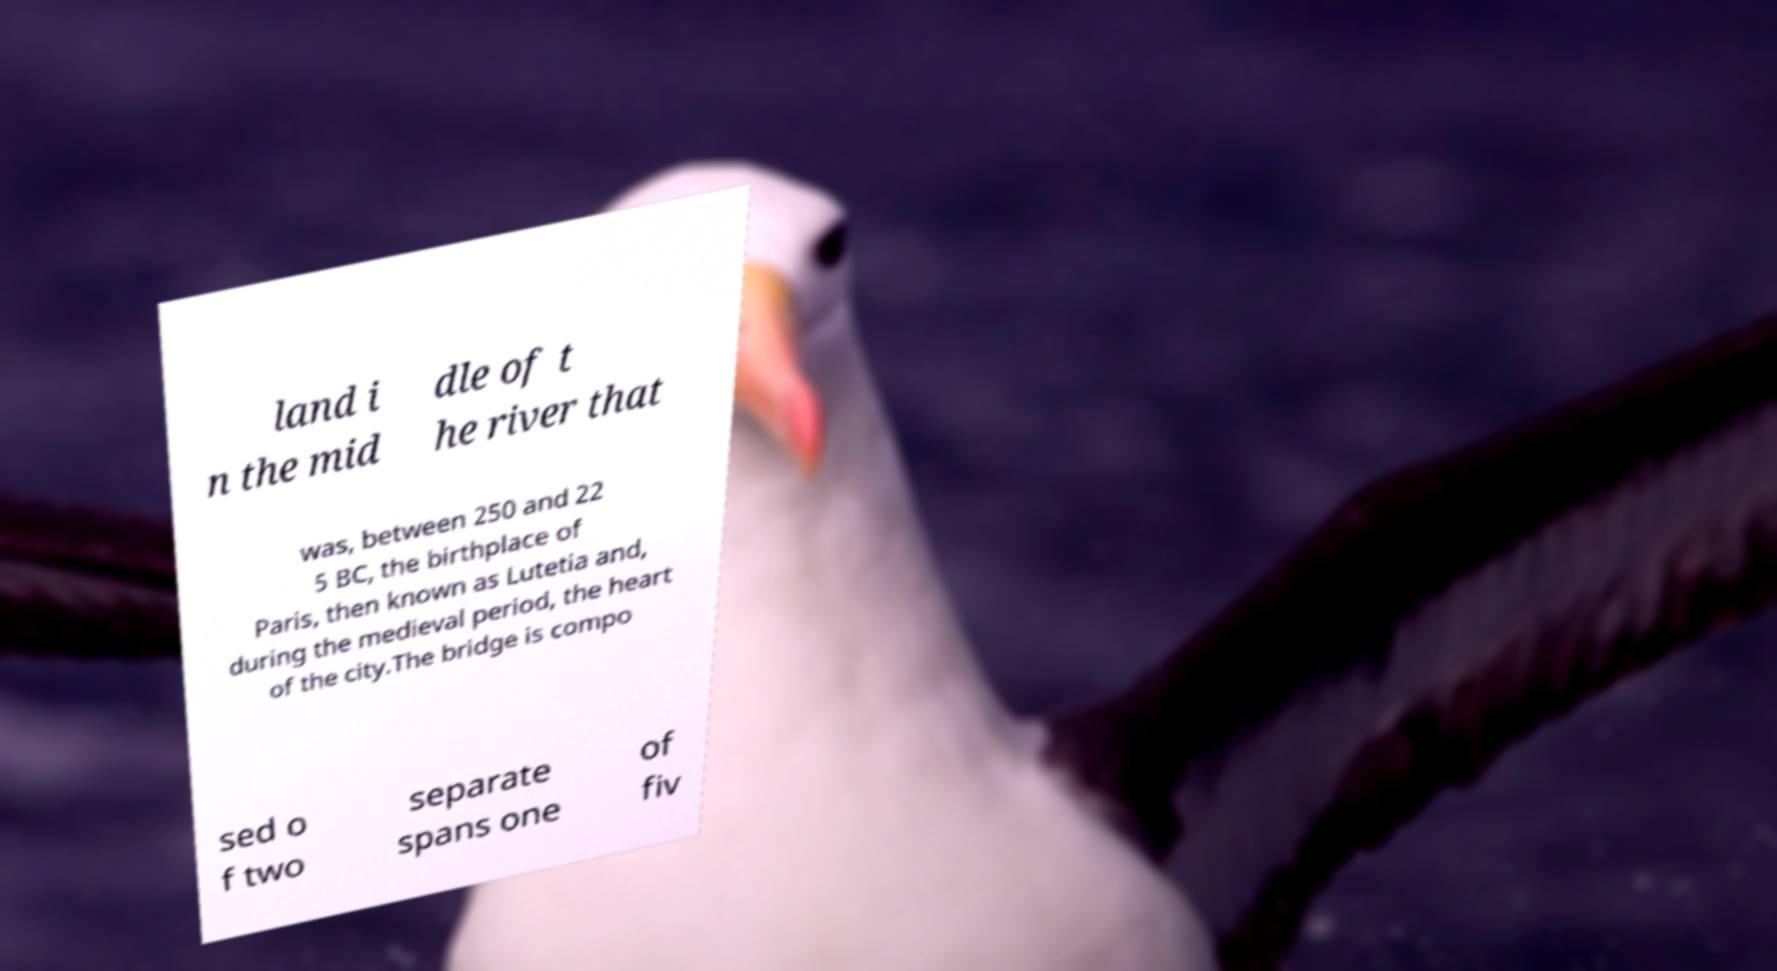For documentation purposes, I need the text within this image transcribed. Could you provide that? land i n the mid dle of t he river that was, between 250 and 22 5 BC, the birthplace of Paris, then known as Lutetia and, during the medieval period, the heart of the city.The bridge is compo sed o f two separate spans one of fiv 